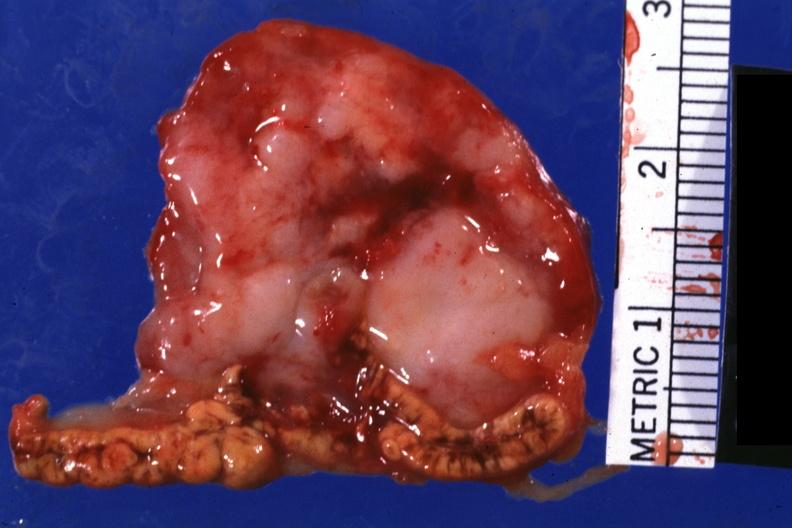s endocrine present?
Answer the question using a single word or phrase. Yes 